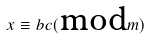<formula> <loc_0><loc_0><loc_500><loc_500>x \equiv b c ( \text {mod} m )</formula> 